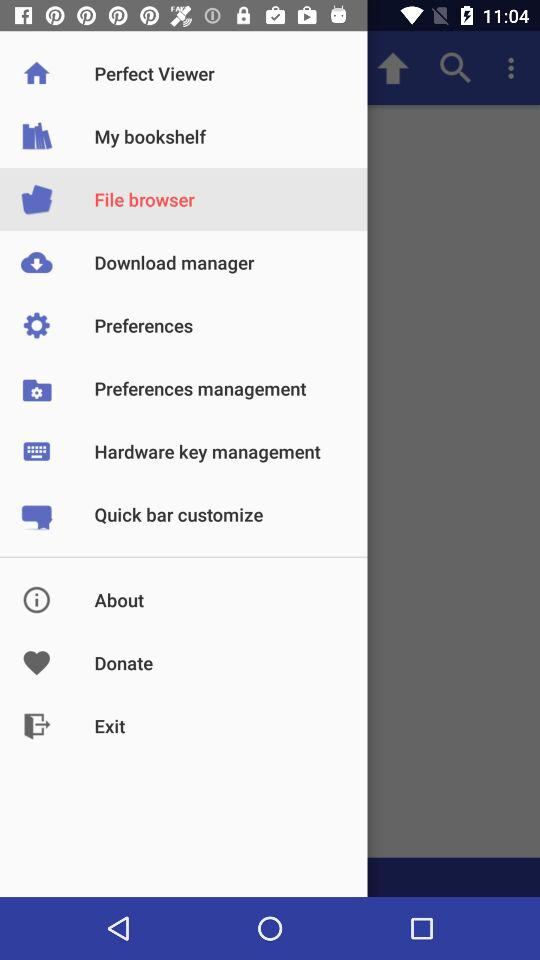Which item is selected? The selected item is "File browser". 